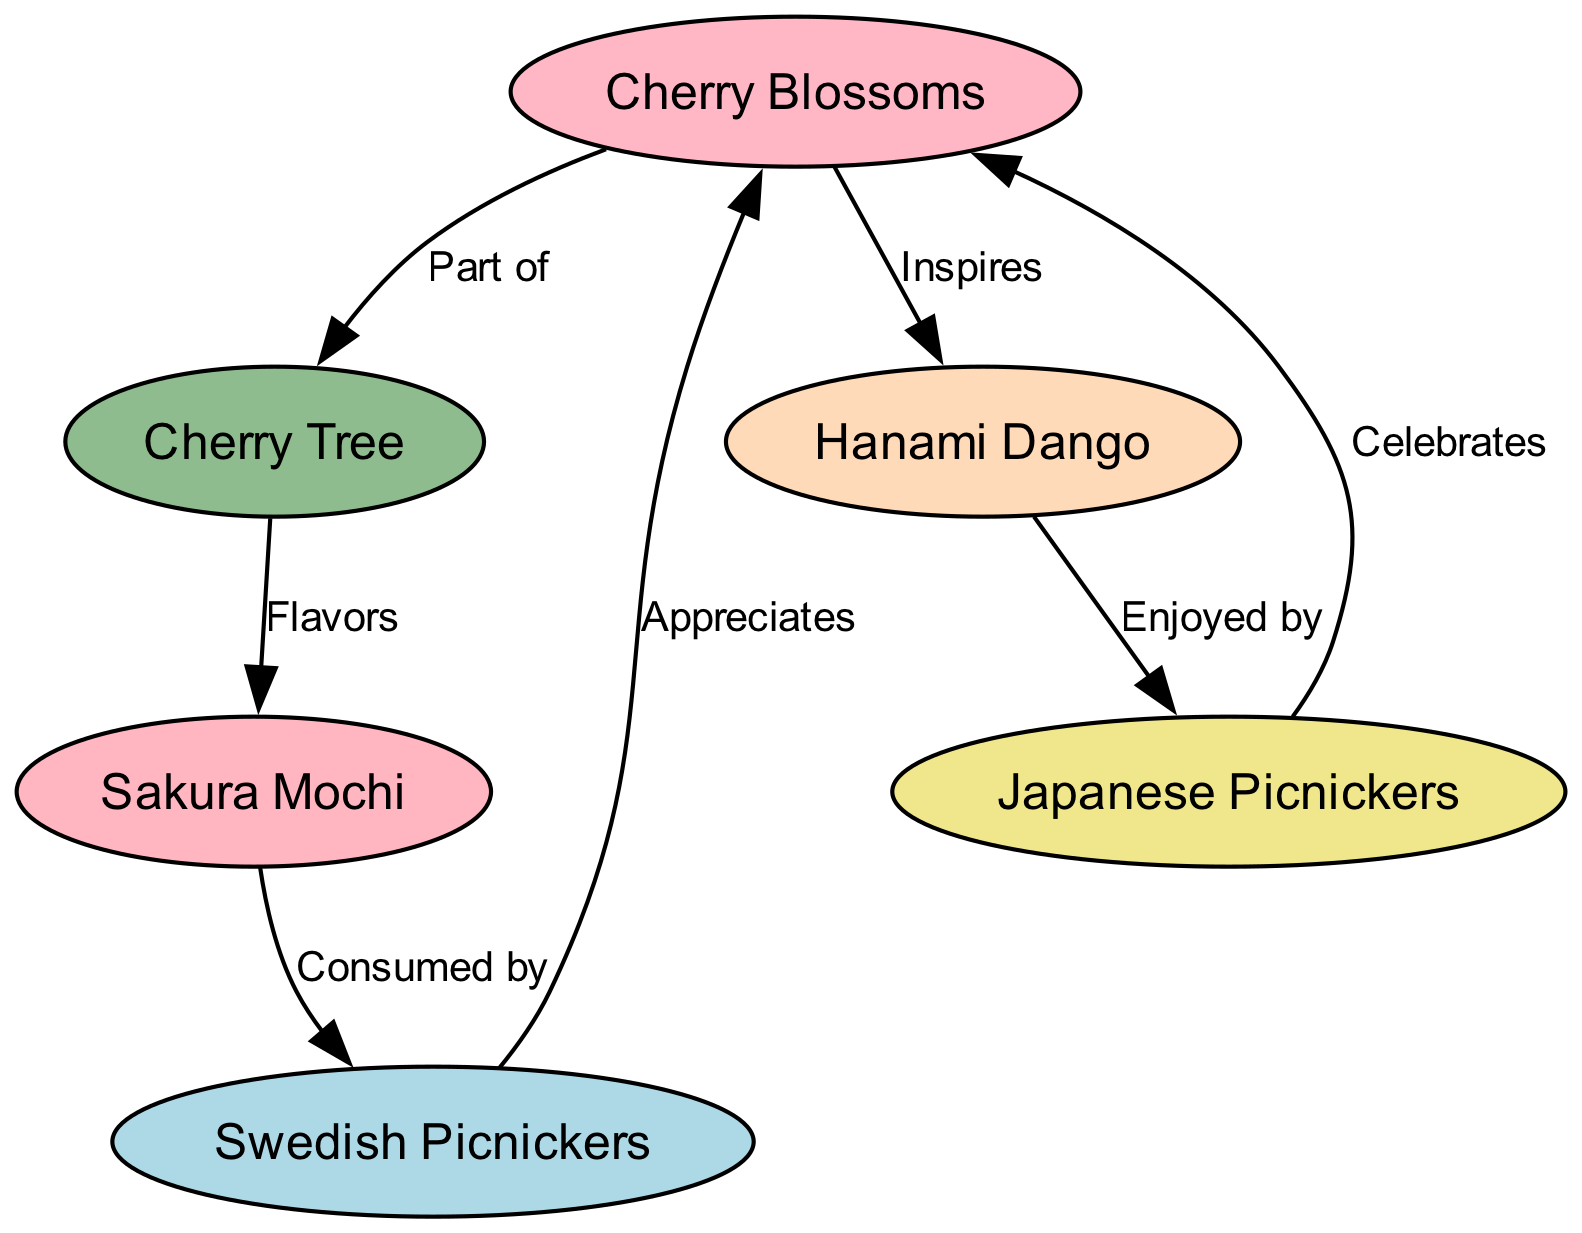What is the total number of nodes in the diagram? The diagram lists the following nodes: Cherry Blossoms, Cherry Tree, Sakura Mochi, Hanami Dango, Swedish Picnickers, and Japanese Picnickers. Counting these gives a total of six nodes.
Answer: 6 Which node is part of the Cherry Blossoms? The edge labeled "Part of" indicates that the Cherry Tree is part of the Cherry Blossoms.
Answer: Cherry Tree Who enjoys Hanami Dango? The diagram shows an edge from Hanami Dango to Japanese Picnickers with the label "Enjoyed by," indicating that Japanese Picnickers are the ones who enjoy Hanami Dango.
Answer: Japanese Picnickers How many edges connect nodes in the diagram? By examining the edges provided, there are six edges connecting the nodes: from Cherry Blossoms to Cherry Tree, from Cherry Tree to Sakura Mochi, from Cherry Blossoms to Hanami Dango, from Sakura Mochi to Swedish Picnickers, from Hanami Dango to Japanese Picnickers, and from both picnickers back to Cherry Blossoms. Counting these gives a total of six edges.
Answer: 6 Which node is consumed by Swedish Picnickers? According to the edge labeled "Consumed by," Sakura Mochi is the node that is consumed by Swedish Picnickers.
Answer: Sakura Mochi What relationship does Cherry Blossoms have with Swedish Picnickers? The diagram illustrates that Swedish Picnickers appreciate Cherry Blossoms as indicated by the edge labeled "Appreciates."
Answer: Appreciates What is the flavor source of Sakura Mochi? The edge labeled "Flavors" leads from Cherry Tree to Sakura Mochi, indicating that the Cherry Tree is the source of flavors for Sakura Mochi.
Answer: Cherry Tree How do Japanese Picnickers interact with Cherry Blossoms? The relationship is shown through the edge labeled "Celebrates," which means that Japanese Picnickers celebrate their connection with Cherry Blossoms.
Answer: Celebrates What type of food is inspired by Cherry Blossoms? The diagram indicates that Hanami Dango is inspired by Cherry Blossoms, as shown by the edge labeled "Inspires."
Answer: Hanami Dango 